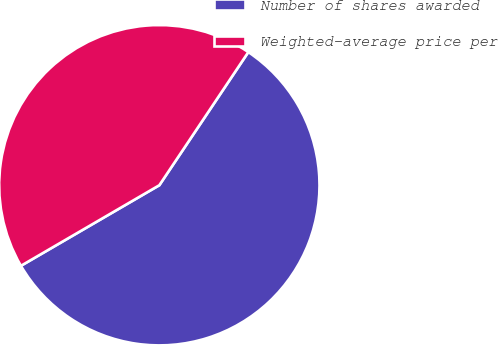Convert chart. <chart><loc_0><loc_0><loc_500><loc_500><pie_chart><fcel>Number of shares awarded<fcel>Weighted-average price per<nl><fcel>57.23%<fcel>42.77%<nl></chart> 